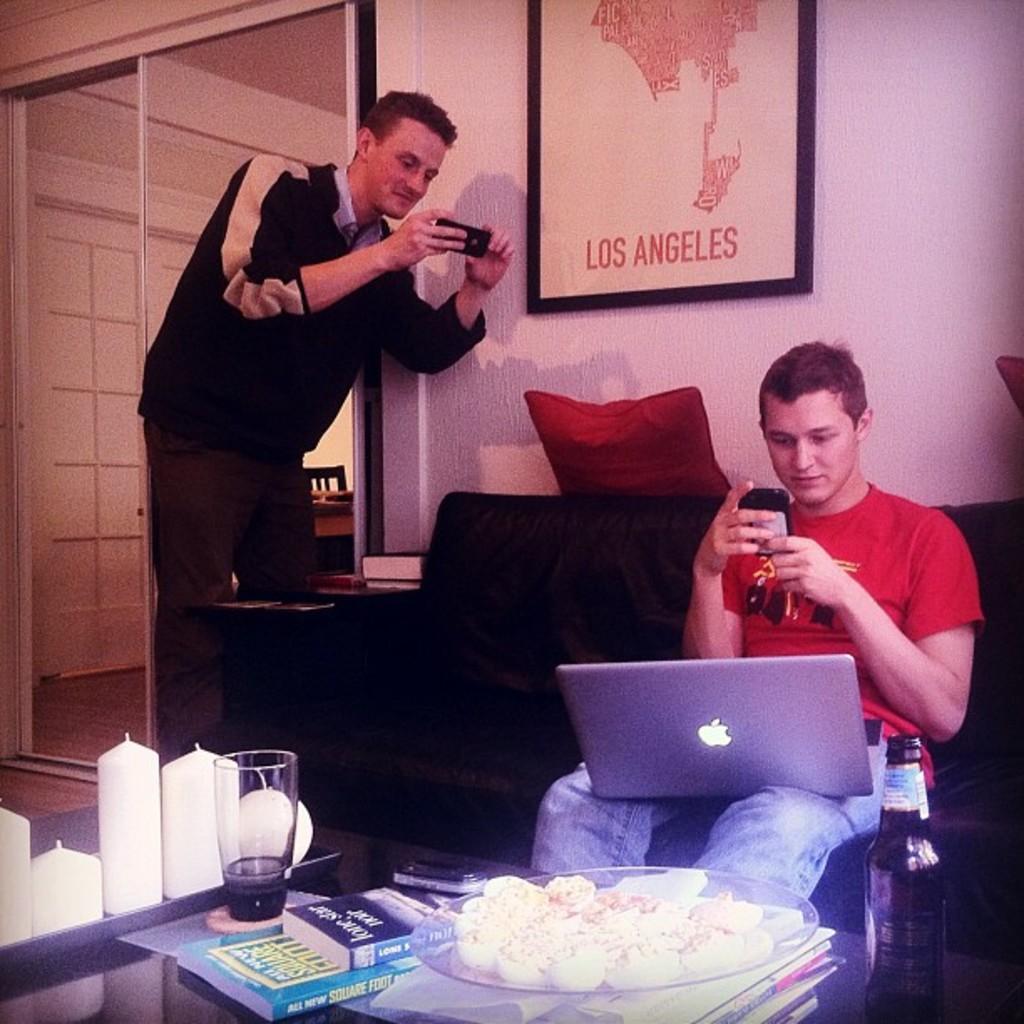How would you summarize this image in a sentence or two? This person standing and holding mobile. This person sitting and holding laptop ,mobile. We can see sofa and table. On the table we can see glass,candle,plate,food,bottle. On the background we can see wall,pillow,poster. 